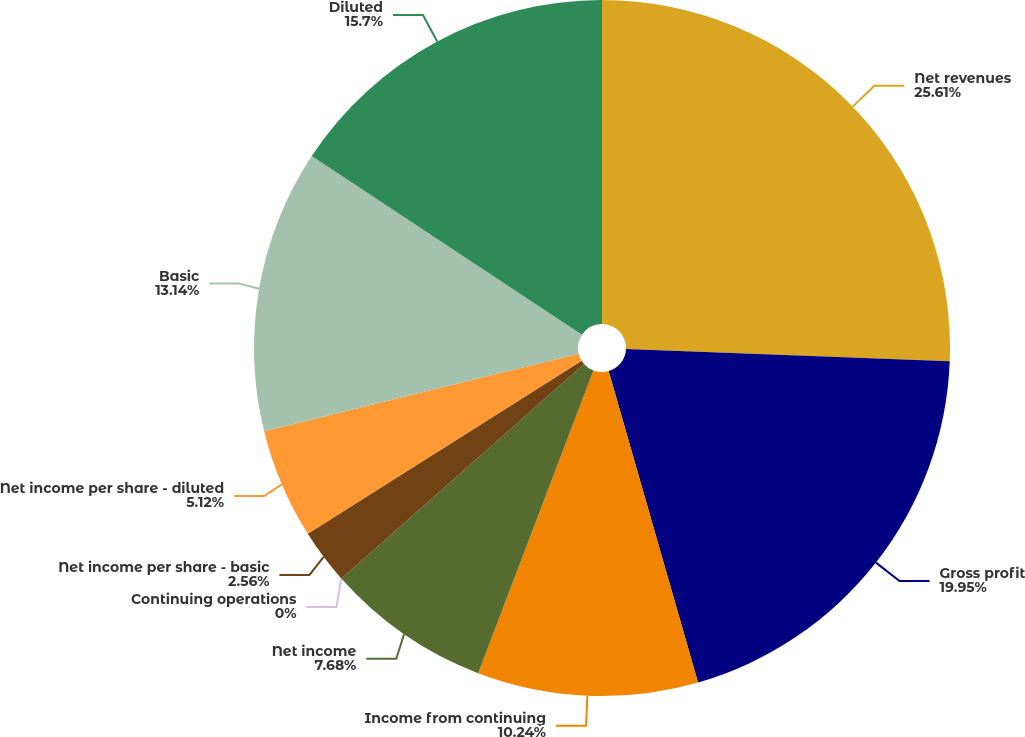<chart> <loc_0><loc_0><loc_500><loc_500><pie_chart><fcel>Net revenues<fcel>Gross profit<fcel>Income from continuing<fcel>Net income<fcel>Continuing operations<fcel>Net income per share - basic<fcel>Net income per share - diluted<fcel>Basic<fcel>Diluted<nl><fcel>25.6%<fcel>19.94%<fcel>10.24%<fcel>7.68%<fcel>0.0%<fcel>2.56%<fcel>5.12%<fcel>13.14%<fcel>15.7%<nl></chart> 